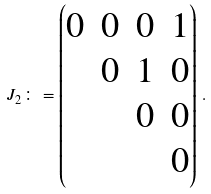<formula> <loc_0><loc_0><loc_500><loc_500>J _ { 2 } \colon = \begin{pmatrix} 0 & 0 & 0 & 1 \\ & 0 & 1 & 0 \\ & & 0 & 0 \\ & & & 0 \end{pmatrix} \, .</formula> 